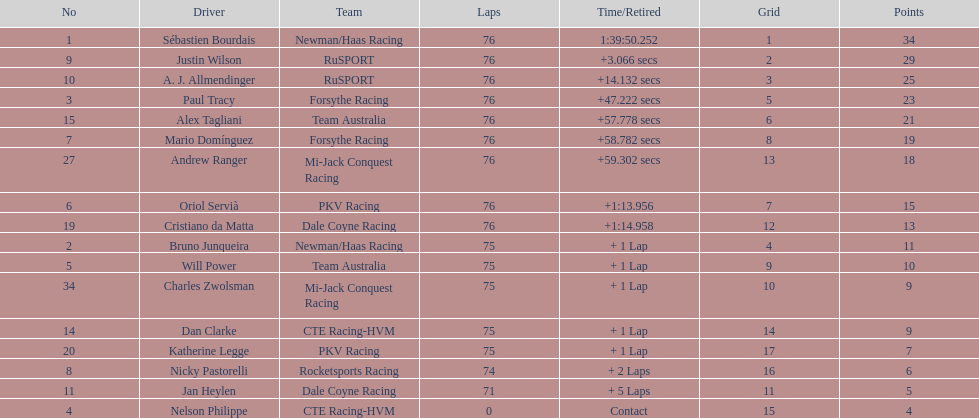What is the total point difference between the driver who received the most points and the driver who received the least? 30. 